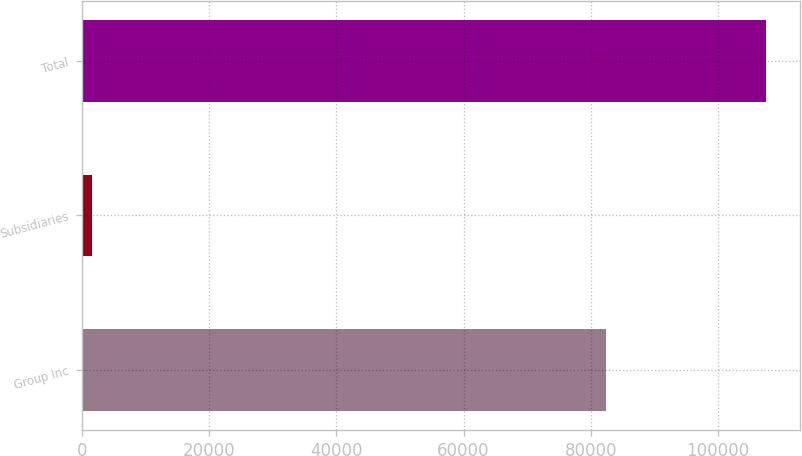Convert chart to OTSL. <chart><loc_0><loc_0><loc_500><loc_500><bar_chart><fcel>Group Inc<fcel>Subsidiaries<fcel>Total<nl><fcel>82396<fcel>1662<fcel>107494<nl></chart> 